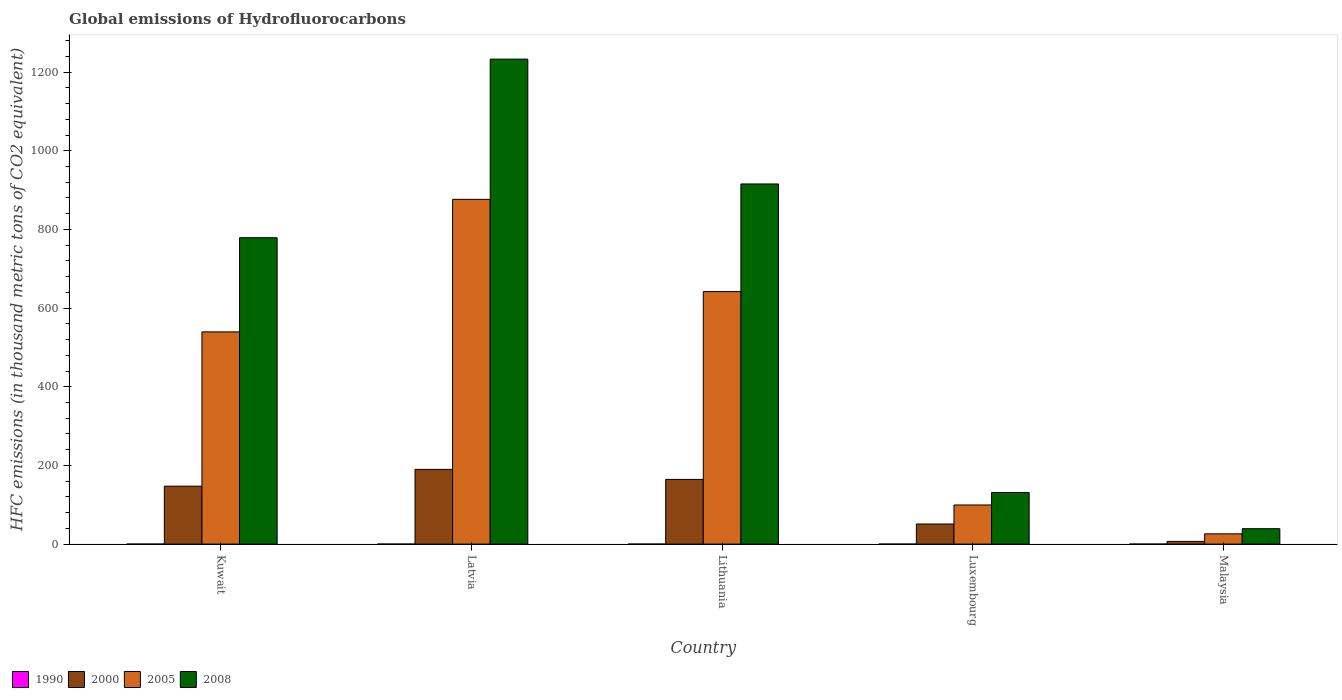How many different coloured bars are there?
Your response must be concise. 4. How many groups of bars are there?
Your answer should be compact. 5. Are the number of bars per tick equal to the number of legend labels?
Your answer should be compact. Yes. How many bars are there on the 4th tick from the right?
Your answer should be compact. 4. What is the label of the 5th group of bars from the left?
Your response must be concise. Malaysia. In how many cases, is the number of bars for a given country not equal to the number of legend labels?
Your answer should be very brief. 0. What is the global emissions of Hydrofluorocarbons in 2000 in Latvia?
Keep it short and to the point. 190. Across all countries, what is the minimum global emissions of Hydrofluorocarbons in 2000?
Make the answer very short. 6.9. In which country was the global emissions of Hydrofluorocarbons in 2005 maximum?
Your answer should be compact. Latvia. In which country was the global emissions of Hydrofluorocarbons in 1990 minimum?
Your answer should be very brief. Kuwait. What is the total global emissions of Hydrofluorocarbons in 2008 in the graph?
Your response must be concise. 3098.2. What is the difference between the global emissions of Hydrofluorocarbons in 2005 in Kuwait and that in Latvia?
Offer a very short reply. -337. What is the difference between the global emissions of Hydrofluorocarbons in 2008 in Lithuania and the global emissions of Hydrofluorocarbons in 1990 in Latvia?
Your answer should be compact. 915.6. What is the average global emissions of Hydrofluorocarbons in 2005 per country?
Your answer should be very brief. 436.78. What is the difference between the global emissions of Hydrofluorocarbons of/in 2008 and global emissions of Hydrofluorocarbons of/in 2005 in Lithuania?
Provide a short and direct response. 273.6. In how many countries, is the global emissions of Hydrofluorocarbons in 1990 greater than 720 thousand metric tons?
Your response must be concise. 0. What is the ratio of the global emissions of Hydrofluorocarbons in 2005 in Lithuania to that in Luxembourg?
Offer a very short reply. 6.45. Is the global emissions of Hydrofluorocarbons in 2008 in Lithuania less than that in Luxembourg?
Provide a short and direct response. No. What is the difference between the highest and the second highest global emissions of Hydrofluorocarbons in 2005?
Provide a short and direct response. 102.5. What is the difference between the highest and the lowest global emissions of Hydrofluorocarbons in 2005?
Your answer should be very brief. 850.5. Is the sum of the global emissions of Hydrofluorocarbons in 2008 in Lithuania and Malaysia greater than the maximum global emissions of Hydrofluorocarbons in 2005 across all countries?
Ensure brevity in your answer.  Yes. What does the 2nd bar from the right in Latvia represents?
Provide a succinct answer. 2005. Is it the case that in every country, the sum of the global emissions of Hydrofluorocarbons in 2005 and global emissions of Hydrofluorocarbons in 2008 is greater than the global emissions of Hydrofluorocarbons in 1990?
Your answer should be very brief. Yes. How many bars are there?
Your answer should be very brief. 20. Are the values on the major ticks of Y-axis written in scientific E-notation?
Ensure brevity in your answer.  No. How many legend labels are there?
Your answer should be compact. 4. What is the title of the graph?
Your answer should be compact. Global emissions of Hydrofluorocarbons. What is the label or title of the X-axis?
Your answer should be very brief. Country. What is the label or title of the Y-axis?
Give a very brief answer. HFC emissions (in thousand metric tons of CO2 equivalent). What is the HFC emissions (in thousand metric tons of CO2 equivalent) in 2000 in Kuwait?
Give a very brief answer. 147.3. What is the HFC emissions (in thousand metric tons of CO2 equivalent) in 2005 in Kuwait?
Give a very brief answer. 539.6. What is the HFC emissions (in thousand metric tons of CO2 equivalent) in 2008 in Kuwait?
Ensure brevity in your answer.  779. What is the HFC emissions (in thousand metric tons of CO2 equivalent) of 1990 in Latvia?
Your response must be concise. 0.1. What is the HFC emissions (in thousand metric tons of CO2 equivalent) in 2000 in Latvia?
Keep it short and to the point. 190. What is the HFC emissions (in thousand metric tons of CO2 equivalent) in 2005 in Latvia?
Make the answer very short. 876.6. What is the HFC emissions (in thousand metric tons of CO2 equivalent) of 2008 in Latvia?
Provide a succinct answer. 1233.1. What is the HFC emissions (in thousand metric tons of CO2 equivalent) in 2000 in Lithuania?
Ensure brevity in your answer.  164.5. What is the HFC emissions (in thousand metric tons of CO2 equivalent) of 2005 in Lithuania?
Your answer should be very brief. 642.1. What is the HFC emissions (in thousand metric tons of CO2 equivalent) of 2008 in Lithuania?
Offer a terse response. 915.7. What is the HFC emissions (in thousand metric tons of CO2 equivalent) of 1990 in Luxembourg?
Your answer should be compact. 0.1. What is the HFC emissions (in thousand metric tons of CO2 equivalent) in 2000 in Luxembourg?
Your answer should be compact. 51.1. What is the HFC emissions (in thousand metric tons of CO2 equivalent) of 2005 in Luxembourg?
Give a very brief answer. 99.5. What is the HFC emissions (in thousand metric tons of CO2 equivalent) in 2008 in Luxembourg?
Provide a succinct answer. 131.2. What is the HFC emissions (in thousand metric tons of CO2 equivalent) in 2000 in Malaysia?
Provide a short and direct response. 6.9. What is the HFC emissions (in thousand metric tons of CO2 equivalent) of 2005 in Malaysia?
Keep it short and to the point. 26.1. What is the HFC emissions (in thousand metric tons of CO2 equivalent) in 2008 in Malaysia?
Your response must be concise. 39.2. Across all countries, what is the maximum HFC emissions (in thousand metric tons of CO2 equivalent) in 2000?
Offer a terse response. 190. Across all countries, what is the maximum HFC emissions (in thousand metric tons of CO2 equivalent) of 2005?
Provide a succinct answer. 876.6. Across all countries, what is the maximum HFC emissions (in thousand metric tons of CO2 equivalent) of 2008?
Provide a succinct answer. 1233.1. Across all countries, what is the minimum HFC emissions (in thousand metric tons of CO2 equivalent) in 1990?
Provide a short and direct response. 0.1. Across all countries, what is the minimum HFC emissions (in thousand metric tons of CO2 equivalent) in 2000?
Offer a very short reply. 6.9. Across all countries, what is the minimum HFC emissions (in thousand metric tons of CO2 equivalent) in 2005?
Give a very brief answer. 26.1. Across all countries, what is the minimum HFC emissions (in thousand metric tons of CO2 equivalent) in 2008?
Offer a very short reply. 39.2. What is the total HFC emissions (in thousand metric tons of CO2 equivalent) in 2000 in the graph?
Provide a succinct answer. 559.8. What is the total HFC emissions (in thousand metric tons of CO2 equivalent) of 2005 in the graph?
Keep it short and to the point. 2183.9. What is the total HFC emissions (in thousand metric tons of CO2 equivalent) in 2008 in the graph?
Ensure brevity in your answer.  3098.2. What is the difference between the HFC emissions (in thousand metric tons of CO2 equivalent) in 2000 in Kuwait and that in Latvia?
Provide a short and direct response. -42.7. What is the difference between the HFC emissions (in thousand metric tons of CO2 equivalent) of 2005 in Kuwait and that in Latvia?
Provide a succinct answer. -337. What is the difference between the HFC emissions (in thousand metric tons of CO2 equivalent) in 2008 in Kuwait and that in Latvia?
Make the answer very short. -454.1. What is the difference between the HFC emissions (in thousand metric tons of CO2 equivalent) in 2000 in Kuwait and that in Lithuania?
Your response must be concise. -17.2. What is the difference between the HFC emissions (in thousand metric tons of CO2 equivalent) in 2005 in Kuwait and that in Lithuania?
Make the answer very short. -102.5. What is the difference between the HFC emissions (in thousand metric tons of CO2 equivalent) in 2008 in Kuwait and that in Lithuania?
Give a very brief answer. -136.7. What is the difference between the HFC emissions (in thousand metric tons of CO2 equivalent) of 2000 in Kuwait and that in Luxembourg?
Provide a short and direct response. 96.2. What is the difference between the HFC emissions (in thousand metric tons of CO2 equivalent) of 2005 in Kuwait and that in Luxembourg?
Make the answer very short. 440.1. What is the difference between the HFC emissions (in thousand metric tons of CO2 equivalent) of 2008 in Kuwait and that in Luxembourg?
Give a very brief answer. 647.8. What is the difference between the HFC emissions (in thousand metric tons of CO2 equivalent) of 2000 in Kuwait and that in Malaysia?
Provide a short and direct response. 140.4. What is the difference between the HFC emissions (in thousand metric tons of CO2 equivalent) in 2005 in Kuwait and that in Malaysia?
Your answer should be compact. 513.5. What is the difference between the HFC emissions (in thousand metric tons of CO2 equivalent) in 2008 in Kuwait and that in Malaysia?
Offer a terse response. 739.8. What is the difference between the HFC emissions (in thousand metric tons of CO2 equivalent) of 2000 in Latvia and that in Lithuania?
Your answer should be very brief. 25.5. What is the difference between the HFC emissions (in thousand metric tons of CO2 equivalent) in 2005 in Latvia and that in Lithuania?
Your answer should be very brief. 234.5. What is the difference between the HFC emissions (in thousand metric tons of CO2 equivalent) in 2008 in Latvia and that in Lithuania?
Your answer should be compact. 317.4. What is the difference between the HFC emissions (in thousand metric tons of CO2 equivalent) of 2000 in Latvia and that in Luxembourg?
Make the answer very short. 138.9. What is the difference between the HFC emissions (in thousand metric tons of CO2 equivalent) in 2005 in Latvia and that in Luxembourg?
Keep it short and to the point. 777.1. What is the difference between the HFC emissions (in thousand metric tons of CO2 equivalent) in 2008 in Latvia and that in Luxembourg?
Your response must be concise. 1101.9. What is the difference between the HFC emissions (in thousand metric tons of CO2 equivalent) in 2000 in Latvia and that in Malaysia?
Provide a succinct answer. 183.1. What is the difference between the HFC emissions (in thousand metric tons of CO2 equivalent) in 2005 in Latvia and that in Malaysia?
Keep it short and to the point. 850.5. What is the difference between the HFC emissions (in thousand metric tons of CO2 equivalent) in 2008 in Latvia and that in Malaysia?
Make the answer very short. 1193.9. What is the difference between the HFC emissions (in thousand metric tons of CO2 equivalent) of 2000 in Lithuania and that in Luxembourg?
Your response must be concise. 113.4. What is the difference between the HFC emissions (in thousand metric tons of CO2 equivalent) of 2005 in Lithuania and that in Luxembourg?
Make the answer very short. 542.6. What is the difference between the HFC emissions (in thousand metric tons of CO2 equivalent) of 2008 in Lithuania and that in Luxembourg?
Make the answer very short. 784.5. What is the difference between the HFC emissions (in thousand metric tons of CO2 equivalent) in 2000 in Lithuania and that in Malaysia?
Keep it short and to the point. 157.6. What is the difference between the HFC emissions (in thousand metric tons of CO2 equivalent) in 2005 in Lithuania and that in Malaysia?
Keep it short and to the point. 616. What is the difference between the HFC emissions (in thousand metric tons of CO2 equivalent) of 2008 in Lithuania and that in Malaysia?
Your answer should be very brief. 876.5. What is the difference between the HFC emissions (in thousand metric tons of CO2 equivalent) of 2000 in Luxembourg and that in Malaysia?
Keep it short and to the point. 44.2. What is the difference between the HFC emissions (in thousand metric tons of CO2 equivalent) of 2005 in Luxembourg and that in Malaysia?
Provide a short and direct response. 73.4. What is the difference between the HFC emissions (in thousand metric tons of CO2 equivalent) of 2008 in Luxembourg and that in Malaysia?
Your response must be concise. 92. What is the difference between the HFC emissions (in thousand metric tons of CO2 equivalent) in 1990 in Kuwait and the HFC emissions (in thousand metric tons of CO2 equivalent) in 2000 in Latvia?
Offer a terse response. -189.9. What is the difference between the HFC emissions (in thousand metric tons of CO2 equivalent) of 1990 in Kuwait and the HFC emissions (in thousand metric tons of CO2 equivalent) of 2005 in Latvia?
Provide a short and direct response. -876.5. What is the difference between the HFC emissions (in thousand metric tons of CO2 equivalent) in 1990 in Kuwait and the HFC emissions (in thousand metric tons of CO2 equivalent) in 2008 in Latvia?
Ensure brevity in your answer.  -1233. What is the difference between the HFC emissions (in thousand metric tons of CO2 equivalent) of 2000 in Kuwait and the HFC emissions (in thousand metric tons of CO2 equivalent) of 2005 in Latvia?
Ensure brevity in your answer.  -729.3. What is the difference between the HFC emissions (in thousand metric tons of CO2 equivalent) in 2000 in Kuwait and the HFC emissions (in thousand metric tons of CO2 equivalent) in 2008 in Latvia?
Give a very brief answer. -1085.8. What is the difference between the HFC emissions (in thousand metric tons of CO2 equivalent) in 2005 in Kuwait and the HFC emissions (in thousand metric tons of CO2 equivalent) in 2008 in Latvia?
Your answer should be very brief. -693.5. What is the difference between the HFC emissions (in thousand metric tons of CO2 equivalent) of 1990 in Kuwait and the HFC emissions (in thousand metric tons of CO2 equivalent) of 2000 in Lithuania?
Give a very brief answer. -164.4. What is the difference between the HFC emissions (in thousand metric tons of CO2 equivalent) of 1990 in Kuwait and the HFC emissions (in thousand metric tons of CO2 equivalent) of 2005 in Lithuania?
Offer a very short reply. -642. What is the difference between the HFC emissions (in thousand metric tons of CO2 equivalent) of 1990 in Kuwait and the HFC emissions (in thousand metric tons of CO2 equivalent) of 2008 in Lithuania?
Your answer should be compact. -915.6. What is the difference between the HFC emissions (in thousand metric tons of CO2 equivalent) in 2000 in Kuwait and the HFC emissions (in thousand metric tons of CO2 equivalent) in 2005 in Lithuania?
Provide a succinct answer. -494.8. What is the difference between the HFC emissions (in thousand metric tons of CO2 equivalent) of 2000 in Kuwait and the HFC emissions (in thousand metric tons of CO2 equivalent) of 2008 in Lithuania?
Keep it short and to the point. -768.4. What is the difference between the HFC emissions (in thousand metric tons of CO2 equivalent) of 2005 in Kuwait and the HFC emissions (in thousand metric tons of CO2 equivalent) of 2008 in Lithuania?
Give a very brief answer. -376.1. What is the difference between the HFC emissions (in thousand metric tons of CO2 equivalent) of 1990 in Kuwait and the HFC emissions (in thousand metric tons of CO2 equivalent) of 2000 in Luxembourg?
Your answer should be compact. -51. What is the difference between the HFC emissions (in thousand metric tons of CO2 equivalent) in 1990 in Kuwait and the HFC emissions (in thousand metric tons of CO2 equivalent) in 2005 in Luxembourg?
Ensure brevity in your answer.  -99.4. What is the difference between the HFC emissions (in thousand metric tons of CO2 equivalent) of 1990 in Kuwait and the HFC emissions (in thousand metric tons of CO2 equivalent) of 2008 in Luxembourg?
Make the answer very short. -131.1. What is the difference between the HFC emissions (in thousand metric tons of CO2 equivalent) in 2000 in Kuwait and the HFC emissions (in thousand metric tons of CO2 equivalent) in 2005 in Luxembourg?
Your response must be concise. 47.8. What is the difference between the HFC emissions (in thousand metric tons of CO2 equivalent) in 2005 in Kuwait and the HFC emissions (in thousand metric tons of CO2 equivalent) in 2008 in Luxembourg?
Offer a terse response. 408.4. What is the difference between the HFC emissions (in thousand metric tons of CO2 equivalent) of 1990 in Kuwait and the HFC emissions (in thousand metric tons of CO2 equivalent) of 2000 in Malaysia?
Offer a very short reply. -6.8. What is the difference between the HFC emissions (in thousand metric tons of CO2 equivalent) of 1990 in Kuwait and the HFC emissions (in thousand metric tons of CO2 equivalent) of 2008 in Malaysia?
Give a very brief answer. -39.1. What is the difference between the HFC emissions (in thousand metric tons of CO2 equivalent) of 2000 in Kuwait and the HFC emissions (in thousand metric tons of CO2 equivalent) of 2005 in Malaysia?
Give a very brief answer. 121.2. What is the difference between the HFC emissions (in thousand metric tons of CO2 equivalent) in 2000 in Kuwait and the HFC emissions (in thousand metric tons of CO2 equivalent) in 2008 in Malaysia?
Offer a terse response. 108.1. What is the difference between the HFC emissions (in thousand metric tons of CO2 equivalent) in 2005 in Kuwait and the HFC emissions (in thousand metric tons of CO2 equivalent) in 2008 in Malaysia?
Make the answer very short. 500.4. What is the difference between the HFC emissions (in thousand metric tons of CO2 equivalent) in 1990 in Latvia and the HFC emissions (in thousand metric tons of CO2 equivalent) in 2000 in Lithuania?
Ensure brevity in your answer.  -164.4. What is the difference between the HFC emissions (in thousand metric tons of CO2 equivalent) of 1990 in Latvia and the HFC emissions (in thousand metric tons of CO2 equivalent) of 2005 in Lithuania?
Offer a terse response. -642. What is the difference between the HFC emissions (in thousand metric tons of CO2 equivalent) in 1990 in Latvia and the HFC emissions (in thousand metric tons of CO2 equivalent) in 2008 in Lithuania?
Provide a short and direct response. -915.6. What is the difference between the HFC emissions (in thousand metric tons of CO2 equivalent) of 2000 in Latvia and the HFC emissions (in thousand metric tons of CO2 equivalent) of 2005 in Lithuania?
Give a very brief answer. -452.1. What is the difference between the HFC emissions (in thousand metric tons of CO2 equivalent) in 2000 in Latvia and the HFC emissions (in thousand metric tons of CO2 equivalent) in 2008 in Lithuania?
Offer a terse response. -725.7. What is the difference between the HFC emissions (in thousand metric tons of CO2 equivalent) of 2005 in Latvia and the HFC emissions (in thousand metric tons of CO2 equivalent) of 2008 in Lithuania?
Your answer should be compact. -39.1. What is the difference between the HFC emissions (in thousand metric tons of CO2 equivalent) in 1990 in Latvia and the HFC emissions (in thousand metric tons of CO2 equivalent) in 2000 in Luxembourg?
Provide a succinct answer. -51. What is the difference between the HFC emissions (in thousand metric tons of CO2 equivalent) in 1990 in Latvia and the HFC emissions (in thousand metric tons of CO2 equivalent) in 2005 in Luxembourg?
Provide a succinct answer. -99.4. What is the difference between the HFC emissions (in thousand metric tons of CO2 equivalent) of 1990 in Latvia and the HFC emissions (in thousand metric tons of CO2 equivalent) of 2008 in Luxembourg?
Your response must be concise. -131.1. What is the difference between the HFC emissions (in thousand metric tons of CO2 equivalent) in 2000 in Latvia and the HFC emissions (in thousand metric tons of CO2 equivalent) in 2005 in Luxembourg?
Your response must be concise. 90.5. What is the difference between the HFC emissions (in thousand metric tons of CO2 equivalent) of 2000 in Latvia and the HFC emissions (in thousand metric tons of CO2 equivalent) of 2008 in Luxembourg?
Ensure brevity in your answer.  58.8. What is the difference between the HFC emissions (in thousand metric tons of CO2 equivalent) in 2005 in Latvia and the HFC emissions (in thousand metric tons of CO2 equivalent) in 2008 in Luxembourg?
Provide a short and direct response. 745.4. What is the difference between the HFC emissions (in thousand metric tons of CO2 equivalent) in 1990 in Latvia and the HFC emissions (in thousand metric tons of CO2 equivalent) in 2000 in Malaysia?
Keep it short and to the point. -6.8. What is the difference between the HFC emissions (in thousand metric tons of CO2 equivalent) in 1990 in Latvia and the HFC emissions (in thousand metric tons of CO2 equivalent) in 2005 in Malaysia?
Offer a very short reply. -26. What is the difference between the HFC emissions (in thousand metric tons of CO2 equivalent) in 1990 in Latvia and the HFC emissions (in thousand metric tons of CO2 equivalent) in 2008 in Malaysia?
Provide a succinct answer. -39.1. What is the difference between the HFC emissions (in thousand metric tons of CO2 equivalent) of 2000 in Latvia and the HFC emissions (in thousand metric tons of CO2 equivalent) of 2005 in Malaysia?
Offer a terse response. 163.9. What is the difference between the HFC emissions (in thousand metric tons of CO2 equivalent) of 2000 in Latvia and the HFC emissions (in thousand metric tons of CO2 equivalent) of 2008 in Malaysia?
Your answer should be compact. 150.8. What is the difference between the HFC emissions (in thousand metric tons of CO2 equivalent) of 2005 in Latvia and the HFC emissions (in thousand metric tons of CO2 equivalent) of 2008 in Malaysia?
Your response must be concise. 837.4. What is the difference between the HFC emissions (in thousand metric tons of CO2 equivalent) of 1990 in Lithuania and the HFC emissions (in thousand metric tons of CO2 equivalent) of 2000 in Luxembourg?
Provide a succinct answer. -51. What is the difference between the HFC emissions (in thousand metric tons of CO2 equivalent) of 1990 in Lithuania and the HFC emissions (in thousand metric tons of CO2 equivalent) of 2005 in Luxembourg?
Offer a terse response. -99.4. What is the difference between the HFC emissions (in thousand metric tons of CO2 equivalent) in 1990 in Lithuania and the HFC emissions (in thousand metric tons of CO2 equivalent) in 2008 in Luxembourg?
Keep it short and to the point. -131.1. What is the difference between the HFC emissions (in thousand metric tons of CO2 equivalent) in 2000 in Lithuania and the HFC emissions (in thousand metric tons of CO2 equivalent) in 2008 in Luxembourg?
Your answer should be very brief. 33.3. What is the difference between the HFC emissions (in thousand metric tons of CO2 equivalent) in 2005 in Lithuania and the HFC emissions (in thousand metric tons of CO2 equivalent) in 2008 in Luxembourg?
Your answer should be very brief. 510.9. What is the difference between the HFC emissions (in thousand metric tons of CO2 equivalent) in 1990 in Lithuania and the HFC emissions (in thousand metric tons of CO2 equivalent) in 2000 in Malaysia?
Offer a very short reply. -6.8. What is the difference between the HFC emissions (in thousand metric tons of CO2 equivalent) of 1990 in Lithuania and the HFC emissions (in thousand metric tons of CO2 equivalent) of 2005 in Malaysia?
Provide a succinct answer. -26. What is the difference between the HFC emissions (in thousand metric tons of CO2 equivalent) in 1990 in Lithuania and the HFC emissions (in thousand metric tons of CO2 equivalent) in 2008 in Malaysia?
Your answer should be very brief. -39.1. What is the difference between the HFC emissions (in thousand metric tons of CO2 equivalent) of 2000 in Lithuania and the HFC emissions (in thousand metric tons of CO2 equivalent) of 2005 in Malaysia?
Offer a very short reply. 138.4. What is the difference between the HFC emissions (in thousand metric tons of CO2 equivalent) in 2000 in Lithuania and the HFC emissions (in thousand metric tons of CO2 equivalent) in 2008 in Malaysia?
Your answer should be very brief. 125.3. What is the difference between the HFC emissions (in thousand metric tons of CO2 equivalent) of 2005 in Lithuania and the HFC emissions (in thousand metric tons of CO2 equivalent) of 2008 in Malaysia?
Your answer should be very brief. 602.9. What is the difference between the HFC emissions (in thousand metric tons of CO2 equivalent) in 1990 in Luxembourg and the HFC emissions (in thousand metric tons of CO2 equivalent) in 2005 in Malaysia?
Provide a short and direct response. -26. What is the difference between the HFC emissions (in thousand metric tons of CO2 equivalent) of 1990 in Luxembourg and the HFC emissions (in thousand metric tons of CO2 equivalent) of 2008 in Malaysia?
Your answer should be compact. -39.1. What is the difference between the HFC emissions (in thousand metric tons of CO2 equivalent) of 2000 in Luxembourg and the HFC emissions (in thousand metric tons of CO2 equivalent) of 2005 in Malaysia?
Provide a succinct answer. 25. What is the difference between the HFC emissions (in thousand metric tons of CO2 equivalent) of 2000 in Luxembourg and the HFC emissions (in thousand metric tons of CO2 equivalent) of 2008 in Malaysia?
Provide a short and direct response. 11.9. What is the difference between the HFC emissions (in thousand metric tons of CO2 equivalent) in 2005 in Luxembourg and the HFC emissions (in thousand metric tons of CO2 equivalent) in 2008 in Malaysia?
Provide a short and direct response. 60.3. What is the average HFC emissions (in thousand metric tons of CO2 equivalent) of 1990 per country?
Offer a very short reply. 0.1. What is the average HFC emissions (in thousand metric tons of CO2 equivalent) in 2000 per country?
Provide a succinct answer. 111.96. What is the average HFC emissions (in thousand metric tons of CO2 equivalent) of 2005 per country?
Provide a succinct answer. 436.78. What is the average HFC emissions (in thousand metric tons of CO2 equivalent) in 2008 per country?
Ensure brevity in your answer.  619.64. What is the difference between the HFC emissions (in thousand metric tons of CO2 equivalent) of 1990 and HFC emissions (in thousand metric tons of CO2 equivalent) of 2000 in Kuwait?
Make the answer very short. -147.2. What is the difference between the HFC emissions (in thousand metric tons of CO2 equivalent) of 1990 and HFC emissions (in thousand metric tons of CO2 equivalent) of 2005 in Kuwait?
Make the answer very short. -539.5. What is the difference between the HFC emissions (in thousand metric tons of CO2 equivalent) of 1990 and HFC emissions (in thousand metric tons of CO2 equivalent) of 2008 in Kuwait?
Provide a succinct answer. -778.9. What is the difference between the HFC emissions (in thousand metric tons of CO2 equivalent) of 2000 and HFC emissions (in thousand metric tons of CO2 equivalent) of 2005 in Kuwait?
Offer a terse response. -392.3. What is the difference between the HFC emissions (in thousand metric tons of CO2 equivalent) in 2000 and HFC emissions (in thousand metric tons of CO2 equivalent) in 2008 in Kuwait?
Give a very brief answer. -631.7. What is the difference between the HFC emissions (in thousand metric tons of CO2 equivalent) of 2005 and HFC emissions (in thousand metric tons of CO2 equivalent) of 2008 in Kuwait?
Offer a very short reply. -239.4. What is the difference between the HFC emissions (in thousand metric tons of CO2 equivalent) in 1990 and HFC emissions (in thousand metric tons of CO2 equivalent) in 2000 in Latvia?
Provide a succinct answer. -189.9. What is the difference between the HFC emissions (in thousand metric tons of CO2 equivalent) in 1990 and HFC emissions (in thousand metric tons of CO2 equivalent) in 2005 in Latvia?
Provide a short and direct response. -876.5. What is the difference between the HFC emissions (in thousand metric tons of CO2 equivalent) in 1990 and HFC emissions (in thousand metric tons of CO2 equivalent) in 2008 in Latvia?
Your response must be concise. -1233. What is the difference between the HFC emissions (in thousand metric tons of CO2 equivalent) of 2000 and HFC emissions (in thousand metric tons of CO2 equivalent) of 2005 in Latvia?
Keep it short and to the point. -686.6. What is the difference between the HFC emissions (in thousand metric tons of CO2 equivalent) in 2000 and HFC emissions (in thousand metric tons of CO2 equivalent) in 2008 in Latvia?
Provide a succinct answer. -1043.1. What is the difference between the HFC emissions (in thousand metric tons of CO2 equivalent) in 2005 and HFC emissions (in thousand metric tons of CO2 equivalent) in 2008 in Latvia?
Your answer should be very brief. -356.5. What is the difference between the HFC emissions (in thousand metric tons of CO2 equivalent) of 1990 and HFC emissions (in thousand metric tons of CO2 equivalent) of 2000 in Lithuania?
Provide a succinct answer. -164.4. What is the difference between the HFC emissions (in thousand metric tons of CO2 equivalent) in 1990 and HFC emissions (in thousand metric tons of CO2 equivalent) in 2005 in Lithuania?
Ensure brevity in your answer.  -642. What is the difference between the HFC emissions (in thousand metric tons of CO2 equivalent) of 1990 and HFC emissions (in thousand metric tons of CO2 equivalent) of 2008 in Lithuania?
Ensure brevity in your answer.  -915.6. What is the difference between the HFC emissions (in thousand metric tons of CO2 equivalent) of 2000 and HFC emissions (in thousand metric tons of CO2 equivalent) of 2005 in Lithuania?
Make the answer very short. -477.6. What is the difference between the HFC emissions (in thousand metric tons of CO2 equivalent) of 2000 and HFC emissions (in thousand metric tons of CO2 equivalent) of 2008 in Lithuania?
Offer a terse response. -751.2. What is the difference between the HFC emissions (in thousand metric tons of CO2 equivalent) of 2005 and HFC emissions (in thousand metric tons of CO2 equivalent) of 2008 in Lithuania?
Your answer should be very brief. -273.6. What is the difference between the HFC emissions (in thousand metric tons of CO2 equivalent) of 1990 and HFC emissions (in thousand metric tons of CO2 equivalent) of 2000 in Luxembourg?
Ensure brevity in your answer.  -51. What is the difference between the HFC emissions (in thousand metric tons of CO2 equivalent) of 1990 and HFC emissions (in thousand metric tons of CO2 equivalent) of 2005 in Luxembourg?
Provide a short and direct response. -99.4. What is the difference between the HFC emissions (in thousand metric tons of CO2 equivalent) in 1990 and HFC emissions (in thousand metric tons of CO2 equivalent) in 2008 in Luxembourg?
Make the answer very short. -131.1. What is the difference between the HFC emissions (in thousand metric tons of CO2 equivalent) of 2000 and HFC emissions (in thousand metric tons of CO2 equivalent) of 2005 in Luxembourg?
Your answer should be very brief. -48.4. What is the difference between the HFC emissions (in thousand metric tons of CO2 equivalent) of 2000 and HFC emissions (in thousand metric tons of CO2 equivalent) of 2008 in Luxembourg?
Your answer should be very brief. -80.1. What is the difference between the HFC emissions (in thousand metric tons of CO2 equivalent) in 2005 and HFC emissions (in thousand metric tons of CO2 equivalent) in 2008 in Luxembourg?
Offer a terse response. -31.7. What is the difference between the HFC emissions (in thousand metric tons of CO2 equivalent) of 1990 and HFC emissions (in thousand metric tons of CO2 equivalent) of 2008 in Malaysia?
Make the answer very short. -39.1. What is the difference between the HFC emissions (in thousand metric tons of CO2 equivalent) in 2000 and HFC emissions (in thousand metric tons of CO2 equivalent) in 2005 in Malaysia?
Your answer should be compact. -19.2. What is the difference between the HFC emissions (in thousand metric tons of CO2 equivalent) in 2000 and HFC emissions (in thousand metric tons of CO2 equivalent) in 2008 in Malaysia?
Your answer should be very brief. -32.3. What is the difference between the HFC emissions (in thousand metric tons of CO2 equivalent) in 2005 and HFC emissions (in thousand metric tons of CO2 equivalent) in 2008 in Malaysia?
Make the answer very short. -13.1. What is the ratio of the HFC emissions (in thousand metric tons of CO2 equivalent) in 2000 in Kuwait to that in Latvia?
Provide a succinct answer. 0.78. What is the ratio of the HFC emissions (in thousand metric tons of CO2 equivalent) of 2005 in Kuwait to that in Latvia?
Offer a very short reply. 0.62. What is the ratio of the HFC emissions (in thousand metric tons of CO2 equivalent) in 2008 in Kuwait to that in Latvia?
Provide a succinct answer. 0.63. What is the ratio of the HFC emissions (in thousand metric tons of CO2 equivalent) of 1990 in Kuwait to that in Lithuania?
Offer a very short reply. 1. What is the ratio of the HFC emissions (in thousand metric tons of CO2 equivalent) of 2000 in Kuwait to that in Lithuania?
Provide a short and direct response. 0.9. What is the ratio of the HFC emissions (in thousand metric tons of CO2 equivalent) in 2005 in Kuwait to that in Lithuania?
Provide a short and direct response. 0.84. What is the ratio of the HFC emissions (in thousand metric tons of CO2 equivalent) in 2008 in Kuwait to that in Lithuania?
Your answer should be compact. 0.85. What is the ratio of the HFC emissions (in thousand metric tons of CO2 equivalent) in 2000 in Kuwait to that in Luxembourg?
Offer a terse response. 2.88. What is the ratio of the HFC emissions (in thousand metric tons of CO2 equivalent) in 2005 in Kuwait to that in Luxembourg?
Your response must be concise. 5.42. What is the ratio of the HFC emissions (in thousand metric tons of CO2 equivalent) in 2008 in Kuwait to that in Luxembourg?
Your response must be concise. 5.94. What is the ratio of the HFC emissions (in thousand metric tons of CO2 equivalent) of 1990 in Kuwait to that in Malaysia?
Your response must be concise. 1. What is the ratio of the HFC emissions (in thousand metric tons of CO2 equivalent) of 2000 in Kuwait to that in Malaysia?
Make the answer very short. 21.35. What is the ratio of the HFC emissions (in thousand metric tons of CO2 equivalent) of 2005 in Kuwait to that in Malaysia?
Offer a terse response. 20.67. What is the ratio of the HFC emissions (in thousand metric tons of CO2 equivalent) in 2008 in Kuwait to that in Malaysia?
Your answer should be compact. 19.87. What is the ratio of the HFC emissions (in thousand metric tons of CO2 equivalent) in 1990 in Latvia to that in Lithuania?
Provide a succinct answer. 1. What is the ratio of the HFC emissions (in thousand metric tons of CO2 equivalent) in 2000 in Latvia to that in Lithuania?
Your answer should be very brief. 1.16. What is the ratio of the HFC emissions (in thousand metric tons of CO2 equivalent) in 2005 in Latvia to that in Lithuania?
Offer a terse response. 1.37. What is the ratio of the HFC emissions (in thousand metric tons of CO2 equivalent) in 2008 in Latvia to that in Lithuania?
Keep it short and to the point. 1.35. What is the ratio of the HFC emissions (in thousand metric tons of CO2 equivalent) of 2000 in Latvia to that in Luxembourg?
Your answer should be compact. 3.72. What is the ratio of the HFC emissions (in thousand metric tons of CO2 equivalent) of 2005 in Latvia to that in Luxembourg?
Keep it short and to the point. 8.81. What is the ratio of the HFC emissions (in thousand metric tons of CO2 equivalent) in 2008 in Latvia to that in Luxembourg?
Offer a very short reply. 9.4. What is the ratio of the HFC emissions (in thousand metric tons of CO2 equivalent) in 2000 in Latvia to that in Malaysia?
Your answer should be compact. 27.54. What is the ratio of the HFC emissions (in thousand metric tons of CO2 equivalent) of 2005 in Latvia to that in Malaysia?
Offer a terse response. 33.59. What is the ratio of the HFC emissions (in thousand metric tons of CO2 equivalent) of 2008 in Latvia to that in Malaysia?
Your answer should be very brief. 31.46. What is the ratio of the HFC emissions (in thousand metric tons of CO2 equivalent) in 1990 in Lithuania to that in Luxembourg?
Give a very brief answer. 1. What is the ratio of the HFC emissions (in thousand metric tons of CO2 equivalent) of 2000 in Lithuania to that in Luxembourg?
Provide a succinct answer. 3.22. What is the ratio of the HFC emissions (in thousand metric tons of CO2 equivalent) of 2005 in Lithuania to that in Luxembourg?
Offer a terse response. 6.45. What is the ratio of the HFC emissions (in thousand metric tons of CO2 equivalent) in 2008 in Lithuania to that in Luxembourg?
Your answer should be very brief. 6.98. What is the ratio of the HFC emissions (in thousand metric tons of CO2 equivalent) in 2000 in Lithuania to that in Malaysia?
Give a very brief answer. 23.84. What is the ratio of the HFC emissions (in thousand metric tons of CO2 equivalent) in 2005 in Lithuania to that in Malaysia?
Ensure brevity in your answer.  24.6. What is the ratio of the HFC emissions (in thousand metric tons of CO2 equivalent) of 2008 in Lithuania to that in Malaysia?
Provide a short and direct response. 23.36. What is the ratio of the HFC emissions (in thousand metric tons of CO2 equivalent) in 1990 in Luxembourg to that in Malaysia?
Provide a short and direct response. 1. What is the ratio of the HFC emissions (in thousand metric tons of CO2 equivalent) in 2000 in Luxembourg to that in Malaysia?
Keep it short and to the point. 7.41. What is the ratio of the HFC emissions (in thousand metric tons of CO2 equivalent) of 2005 in Luxembourg to that in Malaysia?
Make the answer very short. 3.81. What is the ratio of the HFC emissions (in thousand metric tons of CO2 equivalent) in 2008 in Luxembourg to that in Malaysia?
Make the answer very short. 3.35. What is the difference between the highest and the second highest HFC emissions (in thousand metric tons of CO2 equivalent) in 1990?
Offer a very short reply. 0. What is the difference between the highest and the second highest HFC emissions (in thousand metric tons of CO2 equivalent) in 2005?
Offer a terse response. 234.5. What is the difference between the highest and the second highest HFC emissions (in thousand metric tons of CO2 equivalent) of 2008?
Provide a succinct answer. 317.4. What is the difference between the highest and the lowest HFC emissions (in thousand metric tons of CO2 equivalent) in 2000?
Make the answer very short. 183.1. What is the difference between the highest and the lowest HFC emissions (in thousand metric tons of CO2 equivalent) in 2005?
Offer a very short reply. 850.5. What is the difference between the highest and the lowest HFC emissions (in thousand metric tons of CO2 equivalent) in 2008?
Your answer should be compact. 1193.9. 